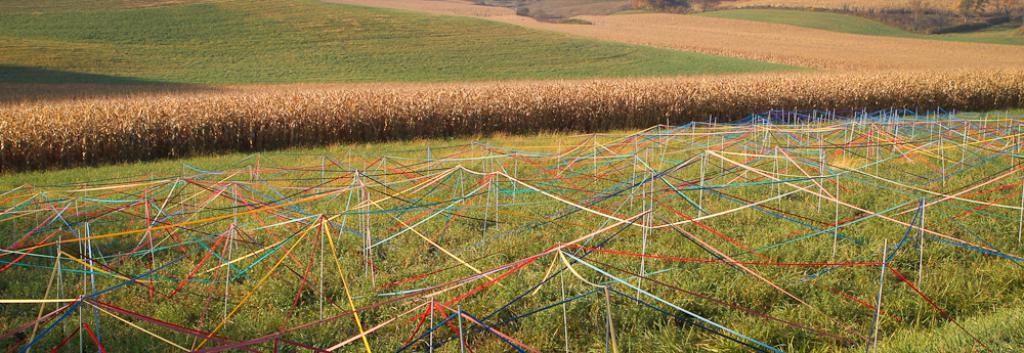What type of vegetation can be seen in the image? There are many crops and grass in the image. Can you describe the area with colorful ribbons? There are colorful ribbons above the grass in a particular area. What type of bird can be seen sitting on the writer's shoulder in the image? There is no writer or bird present in the image; it features crops, grass, and colorful ribbons. 